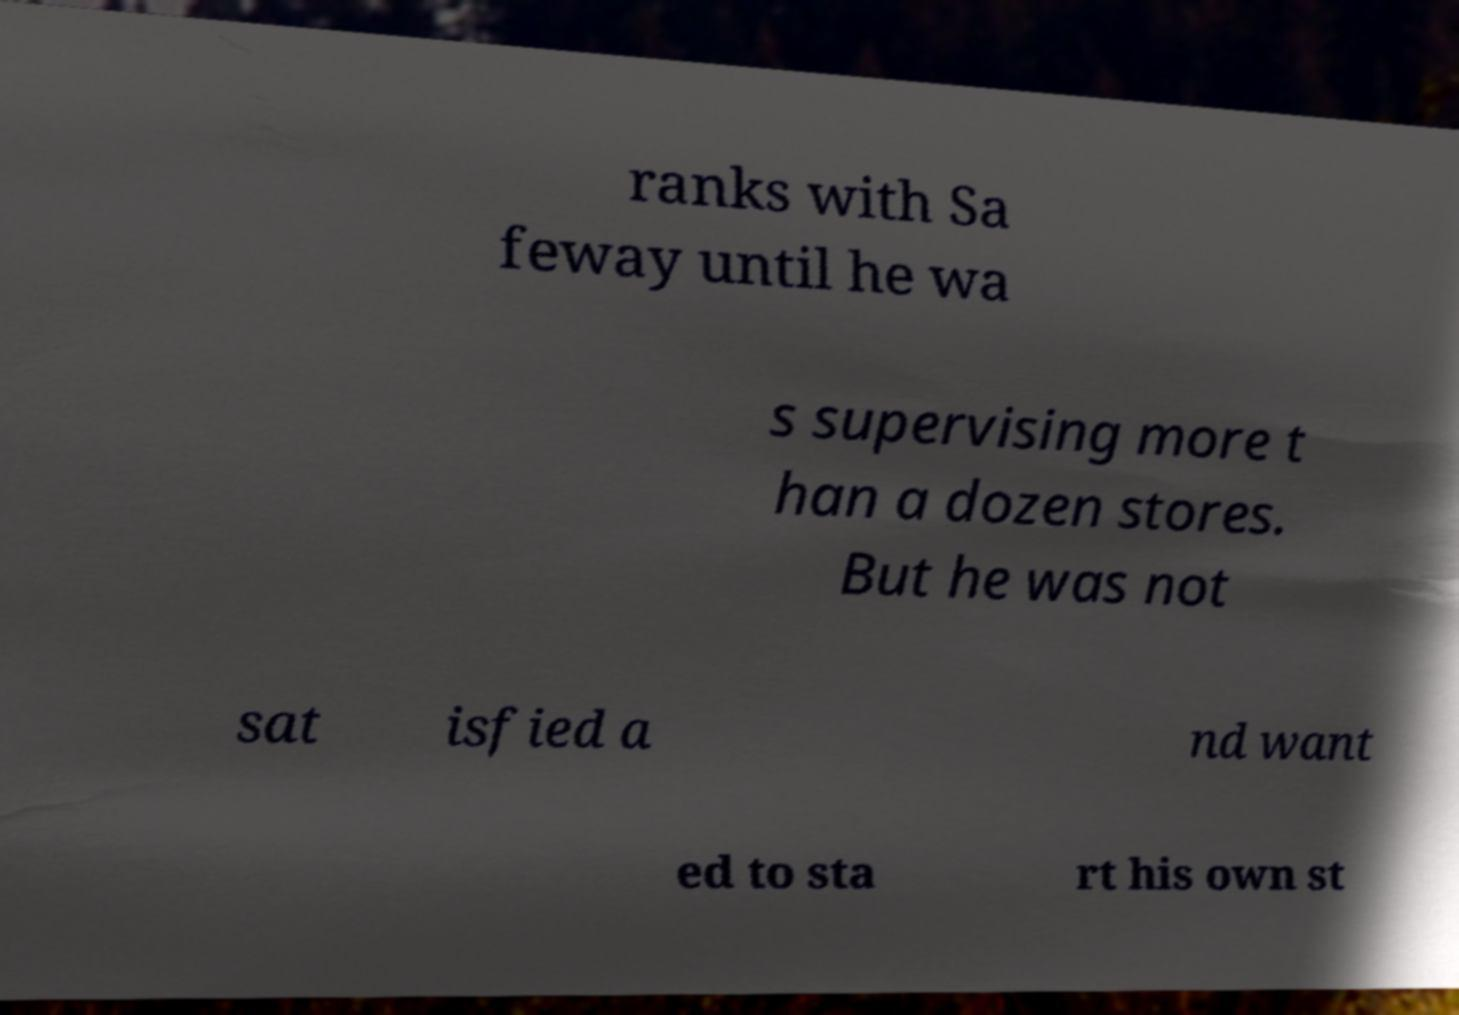Can you accurately transcribe the text from the provided image for me? ranks with Sa feway until he wa s supervising more t han a dozen stores. But he was not sat isfied a nd want ed to sta rt his own st 